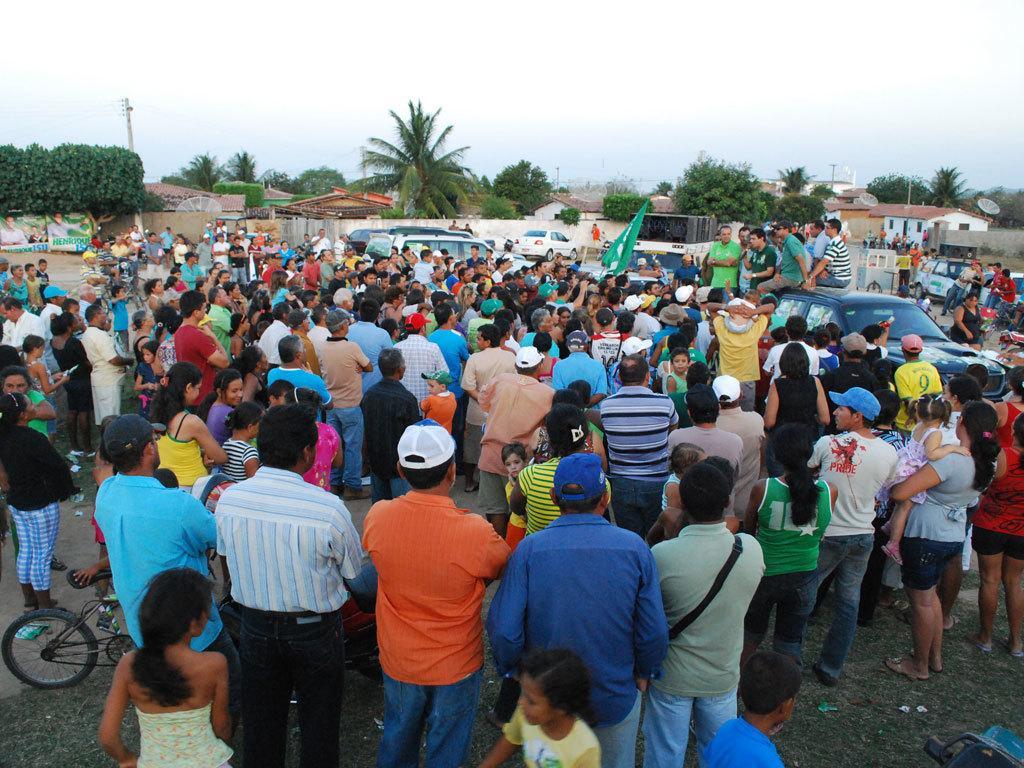Could you give a brief overview of what you see in this image? This image is clicked on the road. There are many people standing on the road. There are vehicles on the road. There are few people sitting on a car. In the background there are houses, trees and poles. To the left there is a hoarding. At the top there is the sky. 